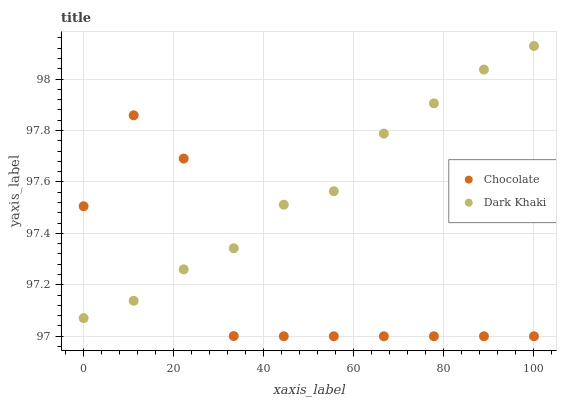Does Chocolate have the minimum area under the curve?
Answer yes or no. Yes. Does Dark Khaki have the maximum area under the curve?
Answer yes or no. Yes. Does Chocolate have the maximum area under the curve?
Answer yes or no. No. Is Dark Khaki the smoothest?
Answer yes or no. Yes. Is Chocolate the roughest?
Answer yes or no. Yes. Is Chocolate the smoothest?
Answer yes or no. No. Does Chocolate have the lowest value?
Answer yes or no. Yes. Does Dark Khaki have the highest value?
Answer yes or no. Yes. Does Chocolate have the highest value?
Answer yes or no. No. Does Dark Khaki intersect Chocolate?
Answer yes or no. Yes. Is Dark Khaki less than Chocolate?
Answer yes or no. No. Is Dark Khaki greater than Chocolate?
Answer yes or no. No. 